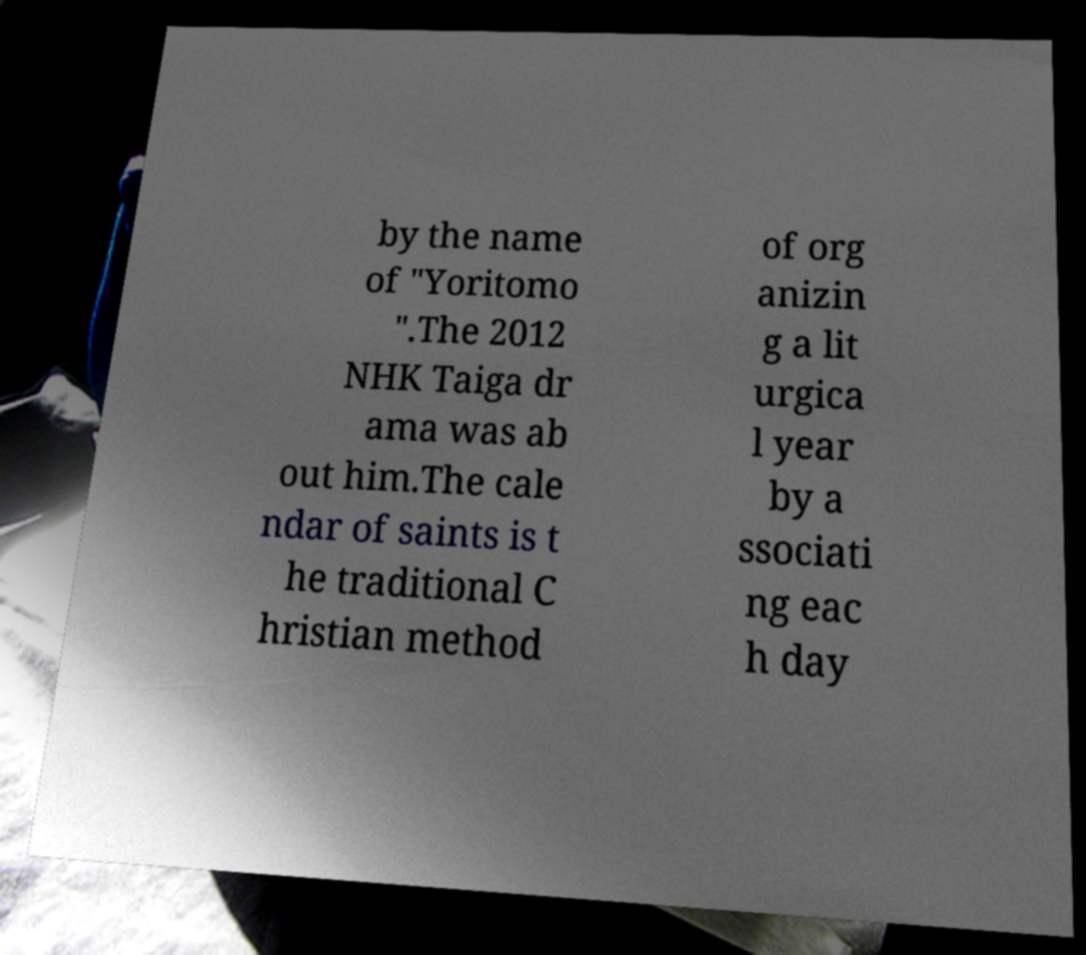Please read and relay the text visible in this image. What does it say? by the name of "Yoritomo ".The 2012 NHK Taiga dr ama was ab out him.The cale ndar of saints is t he traditional C hristian method of org anizin g a lit urgica l year by a ssociati ng eac h day 